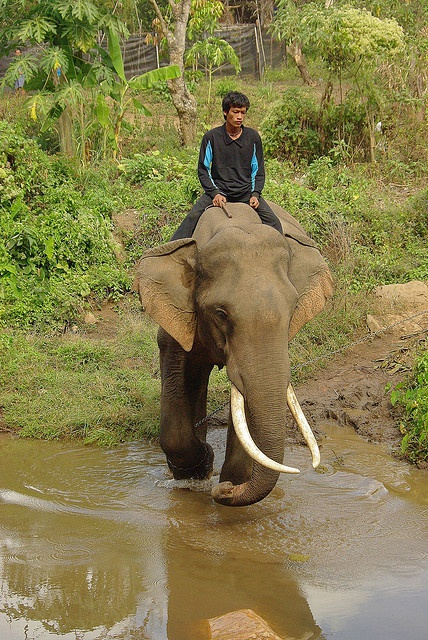Describe the objects in this image and their specific colors. I can see elephant in olive, tan, and black tones and people in olive, black, gray, and maroon tones in this image. 